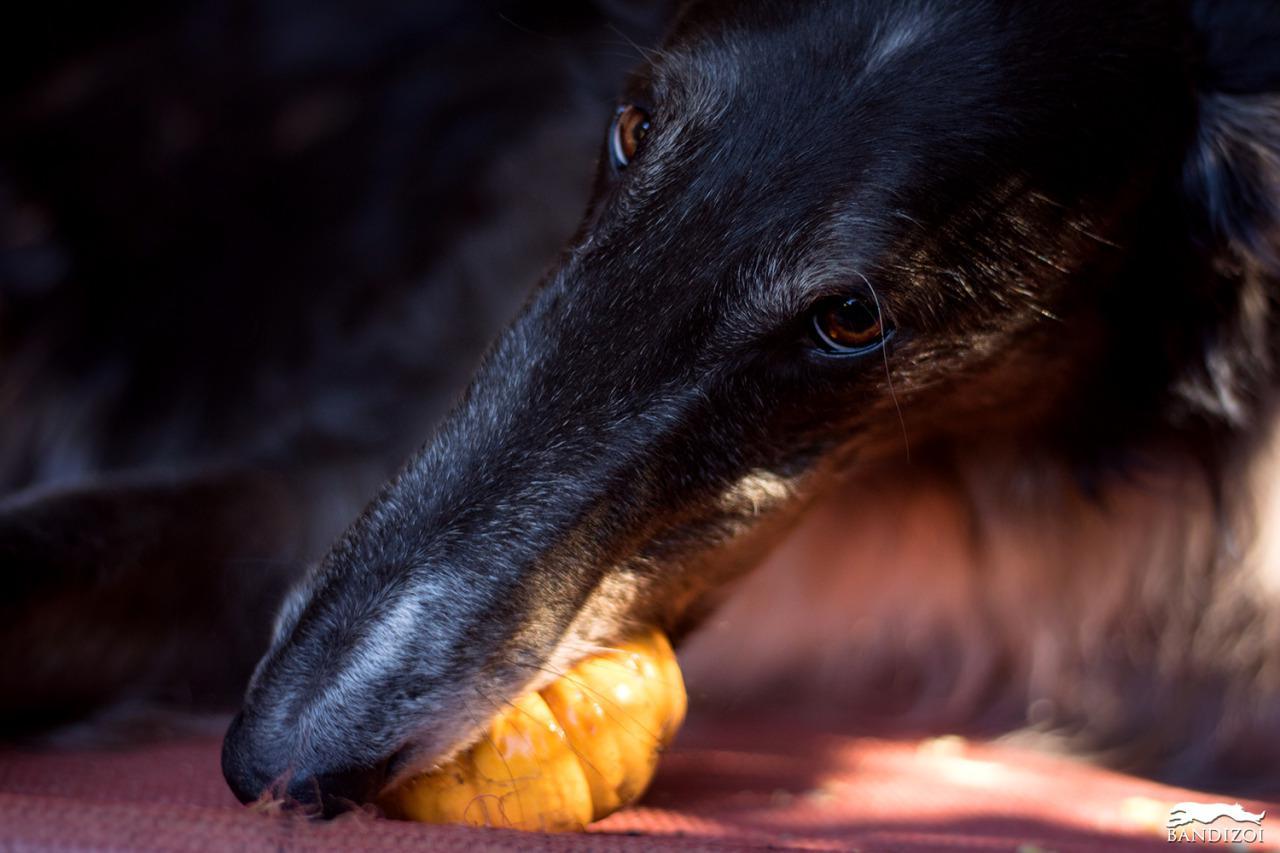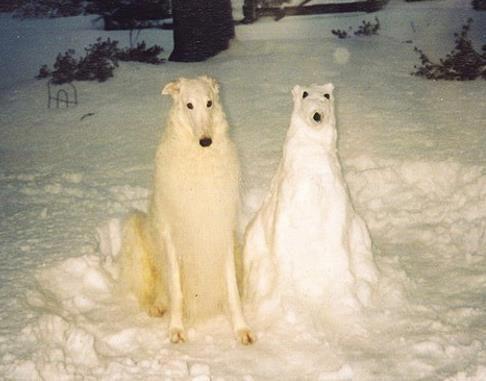The first image is the image on the left, the second image is the image on the right. For the images displayed, is the sentence "At least one of the dogs has its mouth open" factually correct? Answer yes or no. No. The first image is the image on the left, the second image is the image on the right. Given the left and right images, does the statement "The right image contains two dogs." hold true? Answer yes or no. Yes. 